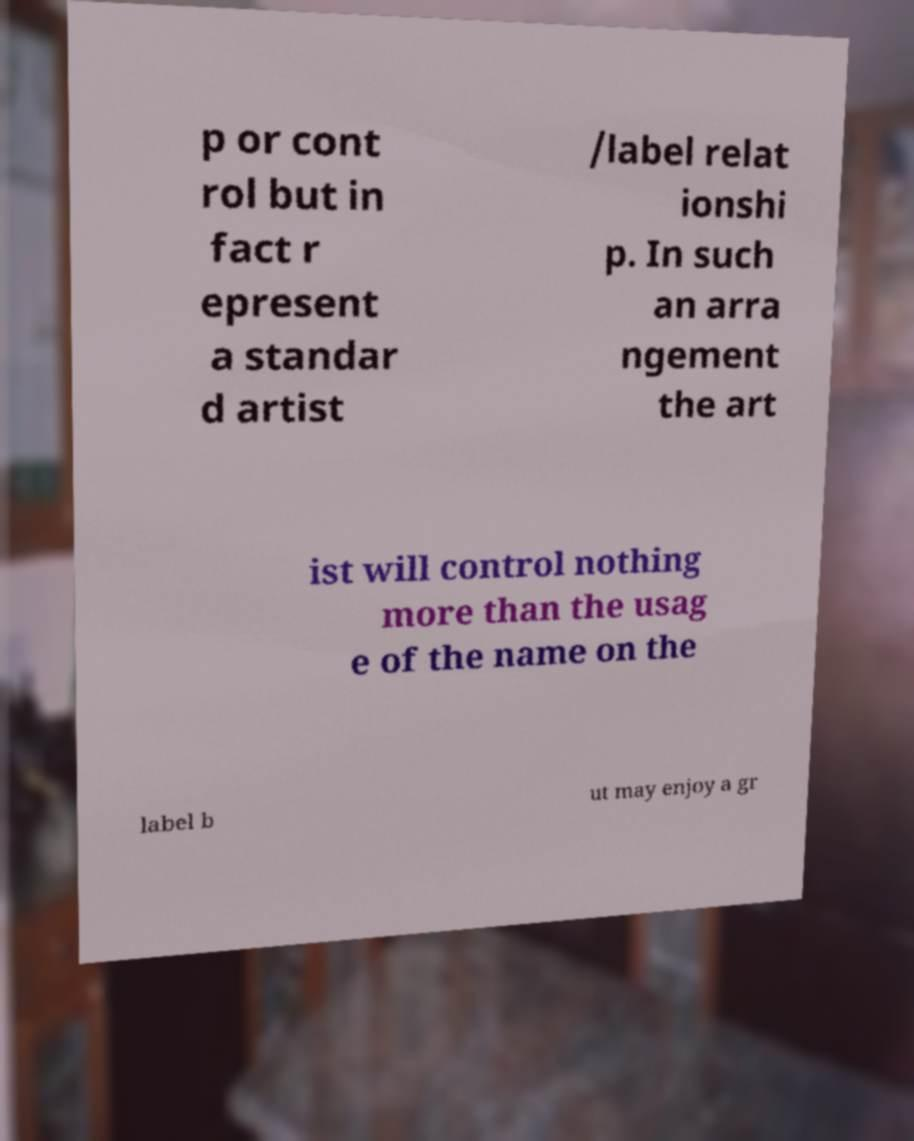Can you read and provide the text displayed in the image?This photo seems to have some interesting text. Can you extract and type it out for me? p or cont rol but in fact r epresent a standar d artist /label relat ionshi p. In such an arra ngement the art ist will control nothing more than the usag e of the name on the label b ut may enjoy a gr 